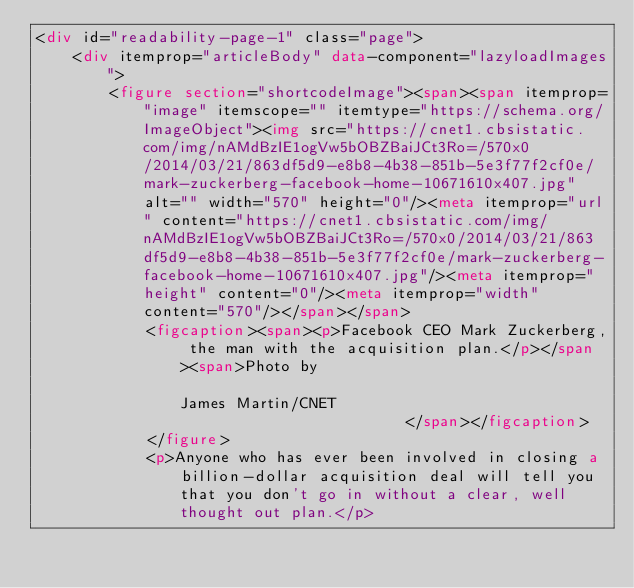<code> <loc_0><loc_0><loc_500><loc_500><_HTML_><div id="readability-page-1" class="page">
    <div itemprop="articleBody" data-component="lazyloadImages">
        <figure section="shortcodeImage"><span><span itemprop="image" itemscope="" itemtype="https://schema.org/ImageObject"><img src="https://cnet1.cbsistatic.com/img/nAMdBzIE1ogVw5bOBZBaiJCt3Ro=/570x0/2014/03/21/863df5d9-e8b8-4b38-851b-5e3f77f2cf0e/mark-zuckerberg-facebook-home-10671610x407.jpg" alt="" width="570" height="0"/><meta itemprop="url" content="https://cnet1.cbsistatic.com/img/nAMdBzIE1ogVw5bOBZBaiJCt3Ro=/570x0/2014/03/21/863df5d9-e8b8-4b38-851b-5e3f77f2cf0e/mark-zuckerberg-facebook-home-10671610x407.jpg"/><meta itemprop="height" content="0"/><meta itemprop="width" content="570"/></span></span>
            <figcaption><span><p>Facebook CEO Mark Zuckerberg, the man with the acquisition plan.</p></span><span>Photo by                                            James Martin/CNET
                                        </span></figcaption>
            </figure>
            <p>Anyone who has ever been involved in closing a billion-dollar acquisition deal will tell you that you don't go in without a clear, well thought out plan.</p></code> 